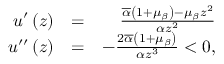Convert formula to latex. <formula><loc_0><loc_0><loc_500><loc_500>\begin{array} { r l r } { u ^ { \prime } \left ( z \right ) } & { = } & { \frac { \overline { \alpha } \left ( 1 + \mu _ { \beta } \right ) - \mu _ { \beta } z ^ { 2 } } { \alpha z ^ { 2 } } } \\ { u ^ { \prime \prime } \left ( z \right ) } & { = } & { - \frac { 2 \overline { \alpha } \left ( 1 + \mu _ { \beta } \right ) } { \alpha z ^ { 3 } } < 0 , } \end{array}</formula> 